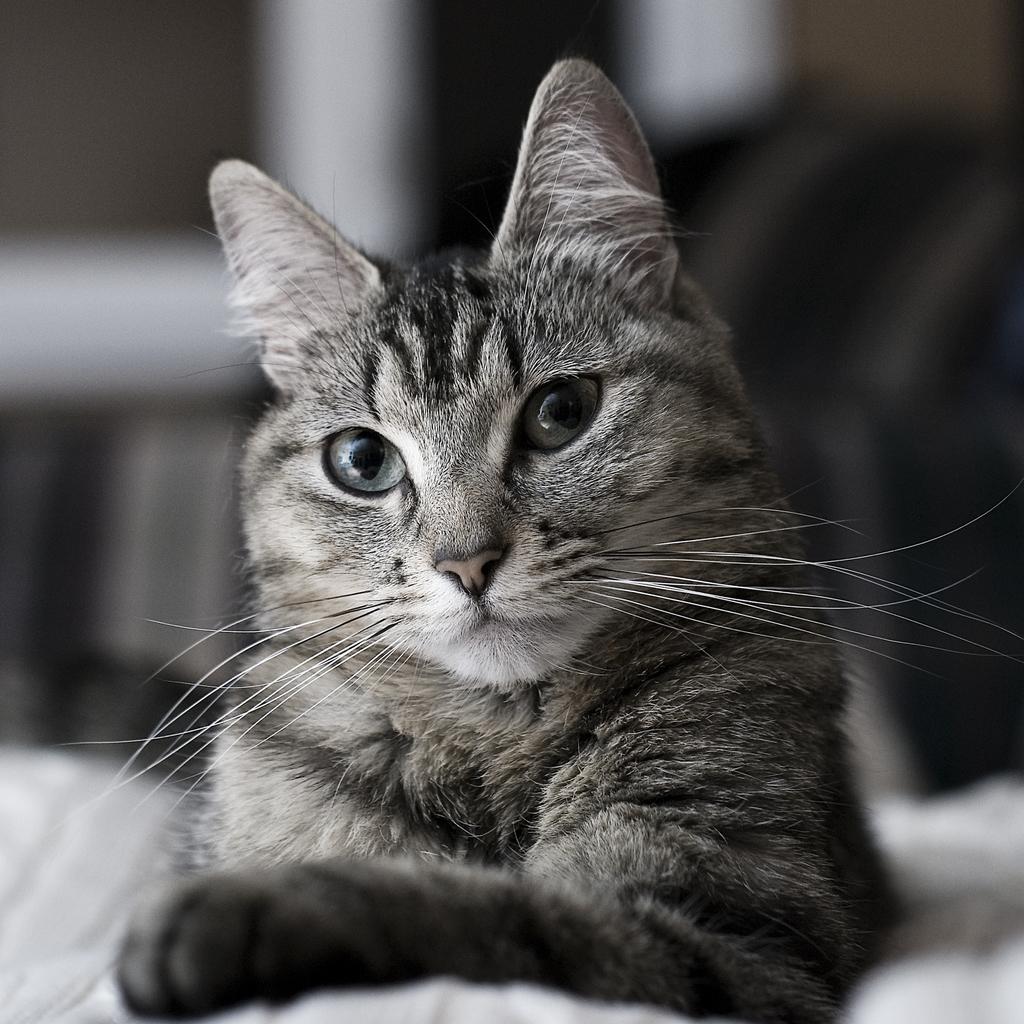In one or two sentences, can you explain what this image depicts? In this image I can see the cat in black and white. Background is blurred. 